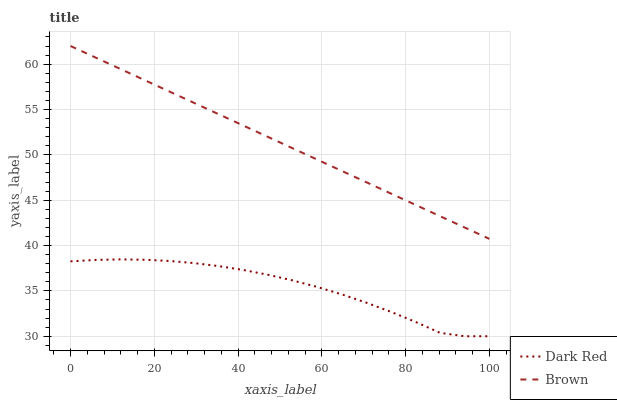Does Dark Red have the minimum area under the curve?
Answer yes or no. Yes. Does Brown have the maximum area under the curve?
Answer yes or no. Yes. Does Brown have the minimum area under the curve?
Answer yes or no. No. Is Brown the smoothest?
Answer yes or no. Yes. Is Dark Red the roughest?
Answer yes or no. Yes. Is Brown the roughest?
Answer yes or no. No. Does Dark Red have the lowest value?
Answer yes or no. Yes. Does Brown have the lowest value?
Answer yes or no. No. Does Brown have the highest value?
Answer yes or no. Yes. Is Dark Red less than Brown?
Answer yes or no. Yes. Is Brown greater than Dark Red?
Answer yes or no. Yes. Does Dark Red intersect Brown?
Answer yes or no. No. 